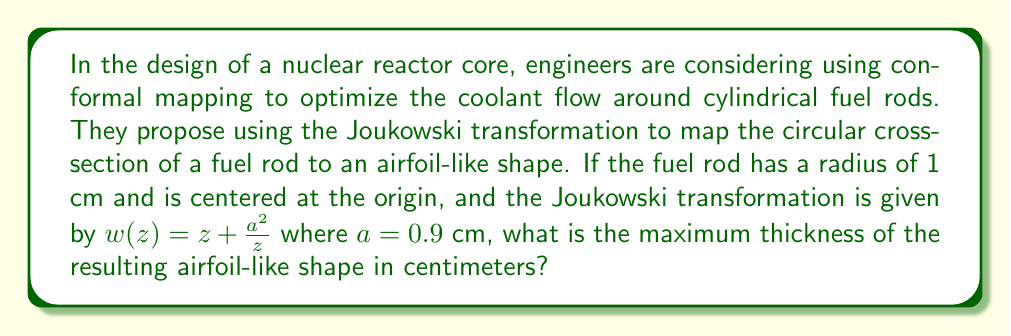Teach me how to tackle this problem. To solve this problem, we'll follow these steps:

1) The Joukowski transformation is given by $w(z) = z + \frac{a^2}{z}$, where $a = 0.9$ cm.

2) For a circle centered at the origin with radius 1 cm, we can parametrize points on the circle as $z = e^{i\theta}$, where $0 \leq \theta < 2\pi$.

3) Substituting this into the transformation:

   $w(e^{i\theta}) = e^{i\theta} + \frac{a^2}{e^{i\theta}} = e^{i\theta} + a^2e^{-i\theta}$

4) We can express this in terms of cosine and sine:

   $w(e^{i\theta}) = (\cos\theta + i\sin\theta) + a^2(\cos\theta - i\sin\theta)$
                  $= (1+a^2)\cos\theta + i(1-a^2)\sin\theta$

5) The real part represents the x-coordinate, and the imaginary part represents the y-coordinate of the transformed shape.

6) The thickness of the airfoil will be maximum when $\theta = \frac{\pi}{2}$ or $\frac{3\pi}{2}$, corresponding to the imaginary part reaching its maximum absolute value.

7) At $\theta = \frac{\pi}{2}$:
   
   $w(e^{i\pi/2}) = i(1-a^2)$

8) The thickness is twice this value:

   Thickness $= 2|1-a^2| = 2(1-0.9^2) = 2(1-0.81) = 2(0.19) = 0.38$ cm

Therefore, the maximum thickness of the resulting airfoil-like shape is 0.38 cm.
Answer: 0.38 cm 